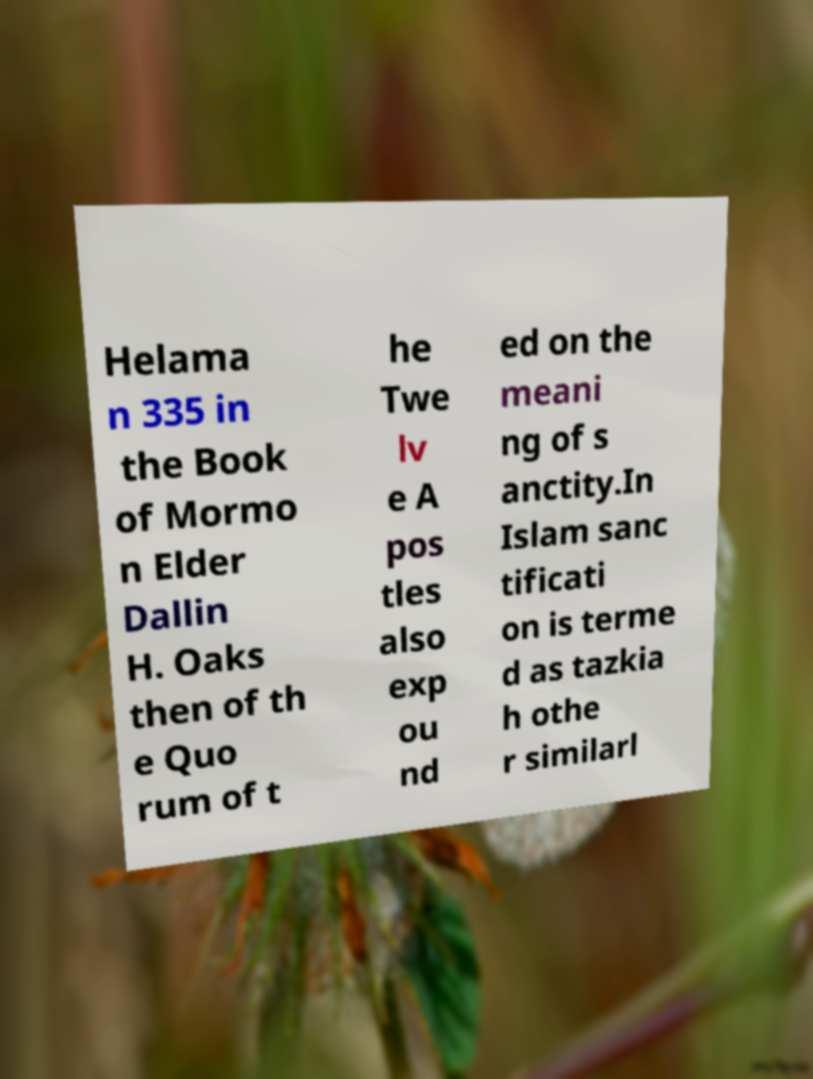There's text embedded in this image that I need extracted. Can you transcribe it verbatim? Helama n 335 in the Book of Mormo n Elder Dallin H. Oaks then of th e Quo rum of t he Twe lv e A pos tles also exp ou nd ed on the meani ng of s anctity.In Islam sanc tificati on is terme d as tazkia h othe r similarl 